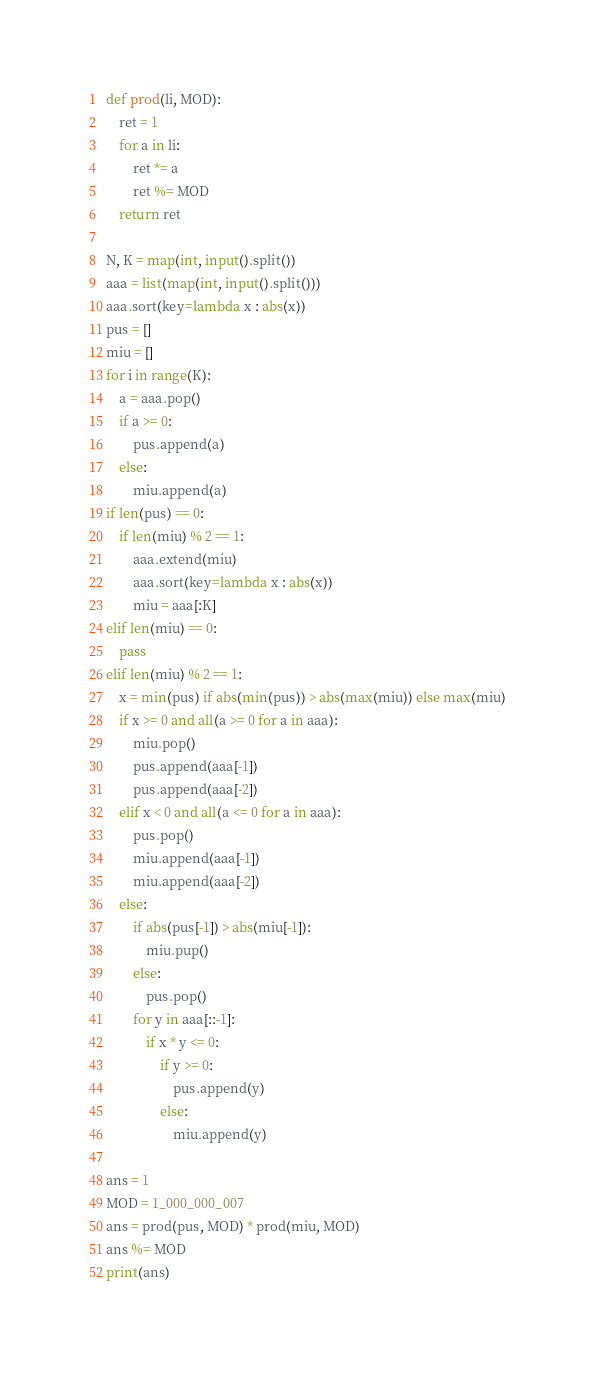Convert code to text. <code><loc_0><loc_0><loc_500><loc_500><_Python_>def prod(li, MOD):
    ret = 1
    for a in li:
        ret *= a
        ret %= MOD
    return ret

N, K = map(int, input().split())
aaa = list(map(int, input().split()))
aaa.sort(key=lambda x : abs(x))
pus = []
miu = []
for i in range(K):
    a = aaa.pop()
    if a >= 0:
        pus.append(a)
    else:
        miu.append(a)
if len(pus) == 0:
    if len(miu) % 2 == 1:
        aaa.extend(miu)
        aaa.sort(key=lambda x : abs(x))
        miu = aaa[:K]
elif len(miu) == 0:
    pass
elif len(miu) % 2 == 1:
    x = min(pus) if abs(min(pus)) > abs(max(miu)) else max(miu)
    if x >= 0 and all(a >= 0 for a in aaa):
        miu.pop()
        pus.append(aaa[-1])
        pus.append(aaa[-2])
    elif x < 0 and all(a <= 0 for a in aaa):
        pus.pop()
        miu.append(aaa[-1])
        miu.append(aaa[-2])
    else:
        if abs(pus[-1]) > abs(miu[-1]):
            miu.pup()
        else:
            pus.pop()
        for y in aaa[::-1]:
            if x * y <= 0:
                if y >= 0:
                    pus.append(y)
                else:
                    miu.append(y)

ans = 1
MOD = 1_000_000_007
ans = prod(pus, MOD) * prod(miu, MOD)
ans %= MOD
print(ans)
</code> 